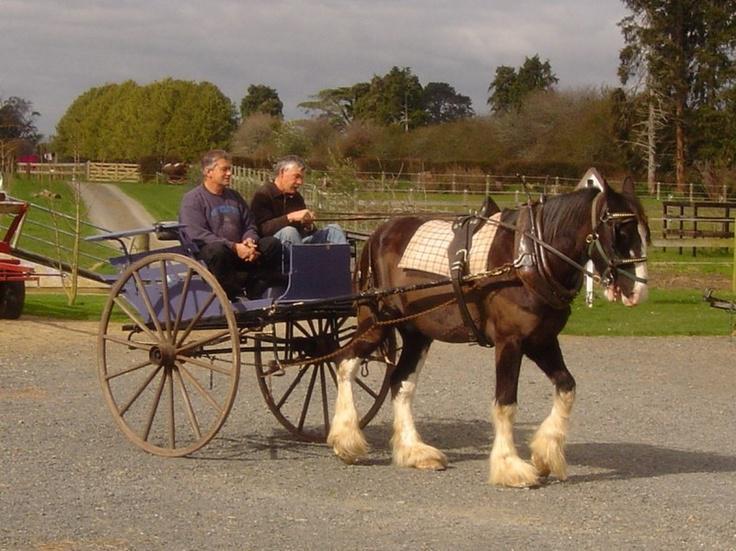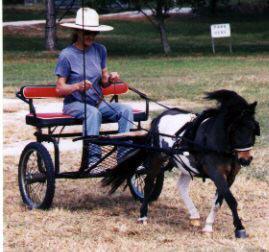The first image is the image on the left, the second image is the image on the right. Evaluate the accuracy of this statement regarding the images: "There is no more than one person in the left image.". Is it true? Answer yes or no. No. The first image is the image on the left, the second image is the image on the right. Given the left and right images, does the statement "A pony's mane hair is flying in the right image." hold true? Answer yes or no. Yes. 